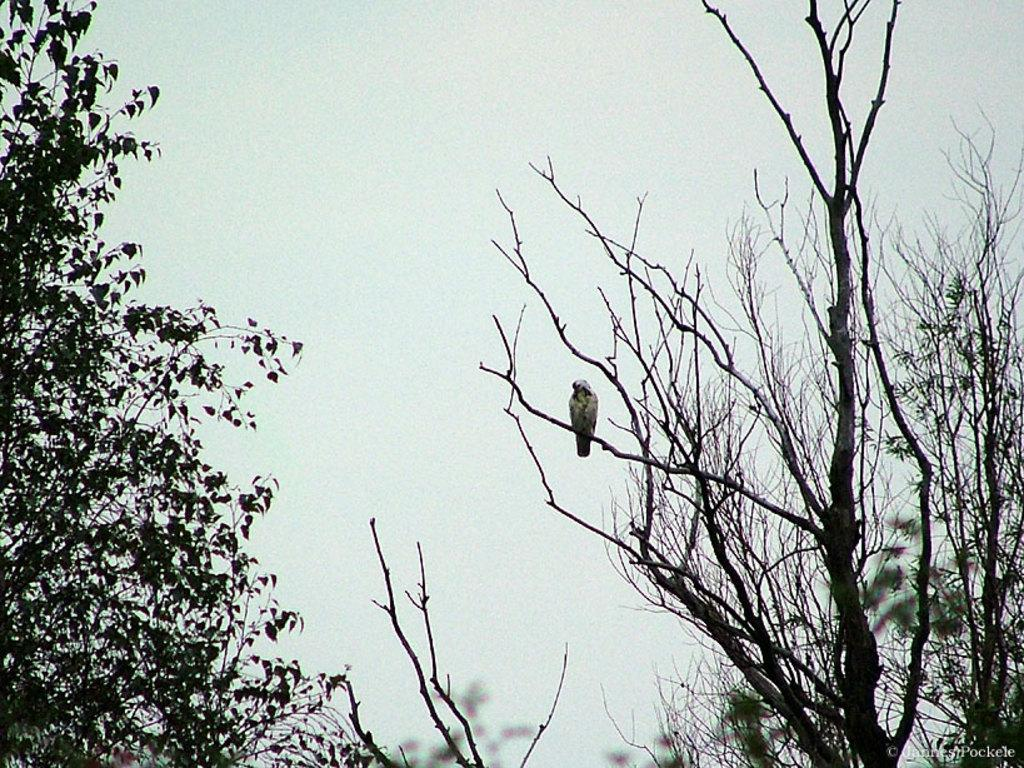What is the main subject of the picture? The main subject of the picture is a bird sitting on a tree. Can you describe the surrounding environment? There are other trees visible in the picture. What is the condition of the sky in the picture? The sky is clear in the picture. What type of plate can be seen in the picture? There is no plate present in the picture; it features a bird sitting on a tree and other trees in the background. 